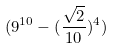Convert formula to latex. <formula><loc_0><loc_0><loc_500><loc_500>( 9 ^ { 1 0 } - ( \frac { \sqrt { 2 } } { 1 0 } ) ^ { 4 } )</formula> 